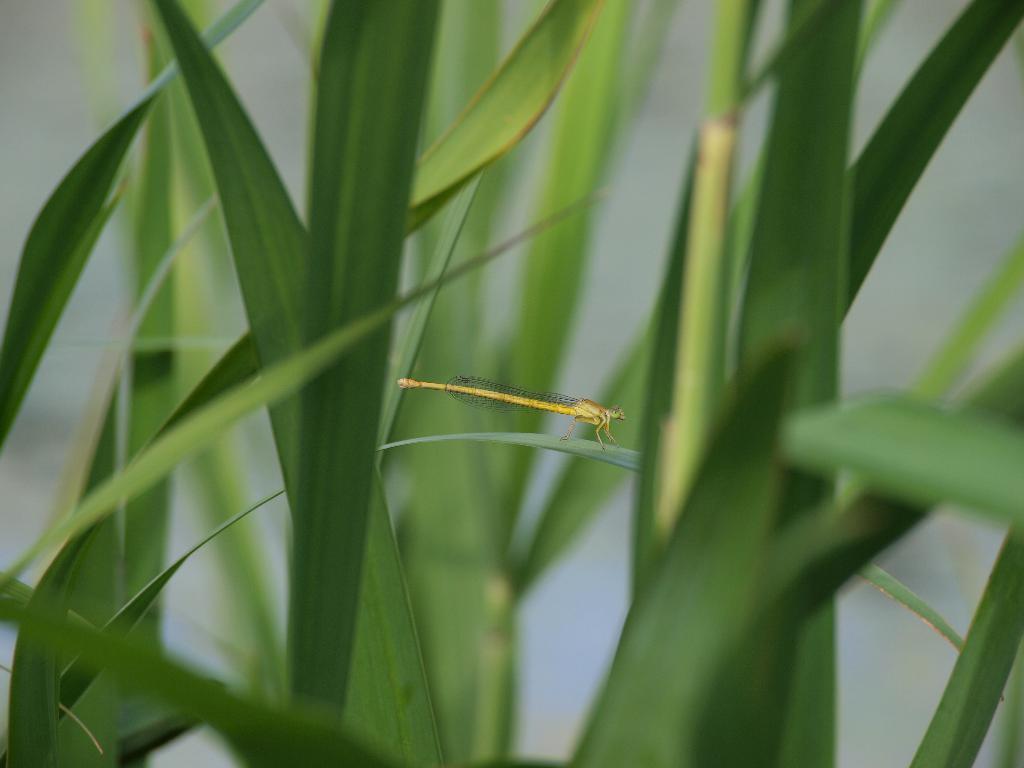Describe this image in one or two sentences. In this image I can see a insect which is yellow in color on the leaf. I can see few plants which are green in color and the white background. 